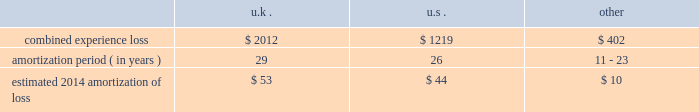Period .
The discount reflects our incremental borrowing rate , which matches the lifetime of the liability .
Significant changes in the discount rate selected or the estimations of sublease income in the case of leases could impact the amounts recorded .
Other associated costs with restructuring activities we recognize other costs associated with restructuring activities as they are incurred , including moving costs and consulting and legal fees .
Pensions we sponsor defined benefit pension plans throughout the world .
Our most significant plans are located in the u.s. , the u.k. , the netherlands and canada .
Our significant u.s. , u.k .
And canadian pension plans are closed to new entrants .
We have ceased crediting future benefits relating to salary and service for our u.s. , u.k .
And canadian plans .
Recognition of gains and losses and prior service certain changes in the value of the obligation and in the value of plan assets , which may occur due to various factors such as changes in the discount rate and actuarial assumptions , actual demographic experience and/or plan asset performance are not immediately recognized in net income .
Such changes are recognized in other comprehensive income and are amortized into net income as part of the net periodic benefit cost .
Unrecognized gains and losses that have been deferred in other comprehensive income , as previously described , are amortized into compensation and benefits expense as a component of periodic pension expense based on the average expected future service of active employees for our plans in the netherlands and canada , or the average life expectancy of the u.s .
And u.k .
Plan members .
After the effective date of the plan amendments to cease crediting future benefits relating to service , unrecognized gains and losses are also be based on the average life expectancy of members in the canadian plans .
We amortize any prior service expense or credits that arise as a result of plan changes over a period consistent with the amortization of gains and losses .
As of december 31 , 2013 , our pension plans have deferred losses that have not yet been recognized through income in the consolidated financial statements .
We amortize unrecognized actuarial losses outside of a corridor , which is defined as 10% ( 10 % ) of the greater of market-related value of plan assets or projected benefit obligation .
To the extent not offset by future gains , incremental amortization as calculated above will continue to affect future pension expense similarly until fully amortized .
The table discloses our combined experience loss , the number of years over which we are amortizing the experience loss , and the estimated 2014 amortization of loss by country ( amounts in millions ) : .
The unrecognized prior service cost at december 31 , 2013 was $ 27 million in the u.k .
And other plans .
For the u.s .
Pension plans we use a market-related valuation of assets approach to determine the expected return on assets , which is a component of net periodic benefit cost recognized in the consolidated statements of income .
This approach recognizes 20% ( 20 % ) of any gains or losses in the current year's value of market-related assets , with the remaining 80% ( 80 % ) spread over the next four years .
As this approach recognizes gains or losses over a five-year period , the future value of assets and therefore , our net periodic benefit cost will be impacted as previously deferred gains or losses are recorded .
As of december 31 , 2013 , the market-related value of assets was $ 1.8 billion .
We do not use the market-related valuation approach to determine the funded status of the u.s .
Plans recorded in the consolidated statements of financial position .
Instead , we record and present the funded status in the consolidated statements of financial position based on the fair value of the plan assets .
As of december 31 , 2013 , the fair value of plan assets was $ 1.9 billion .
Our non-u.s .
Plans use fair value to determine expected return on assets. .
As of december 31 , 2013 , what was the ratio of the fair value of plan assets to the the market-related value of assets was $ 1.9 billion .? 
Computations: (1.9 / 1.8)
Answer: 1.05556. 